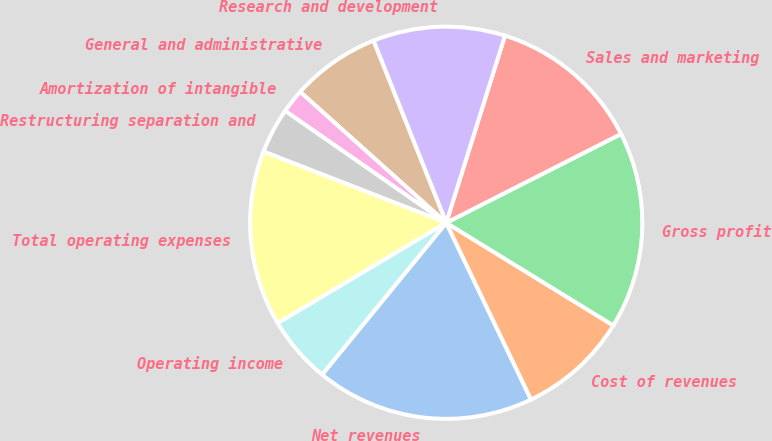Convert chart. <chart><loc_0><loc_0><loc_500><loc_500><pie_chart><fcel>Net revenues<fcel>Cost of revenues<fcel>Gross profit<fcel>Sales and marketing<fcel>Research and development<fcel>General and administrative<fcel>Amortization of intangible<fcel>Restructuring separation and<fcel>Total operating expenses<fcel>Operating income<nl><fcel>18.03%<fcel>9.11%<fcel>16.25%<fcel>12.68%<fcel>10.89%<fcel>7.32%<fcel>1.97%<fcel>3.75%<fcel>14.46%<fcel>5.54%<nl></chart> 